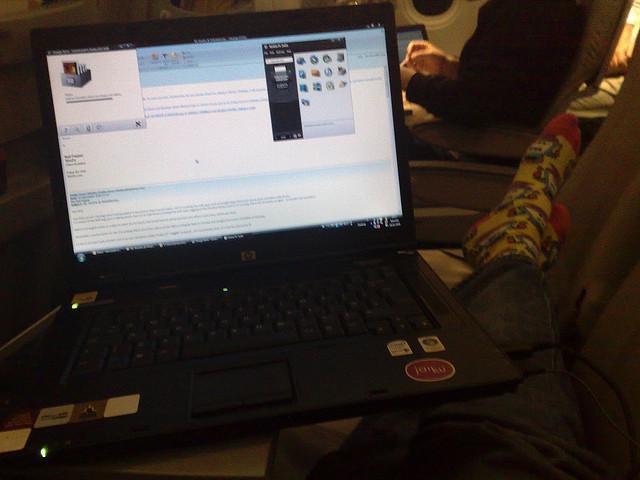How many speakers does the electronic device have?
Give a very brief answer. 2. How many people are there?
Give a very brief answer. 2. How many cows are there?
Give a very brief answer. 0. 